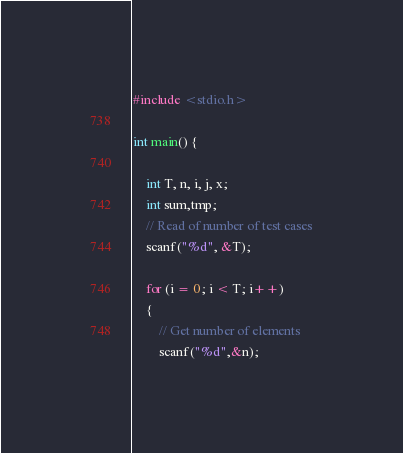Convert code to text. <code><loc_0><loc_0><loc_500><loc_500><_C_>#include <stdio.h>

int main() {

	int T, n, i, j, x;
	int sum,tmp;
	// Read of number of test cases
	scanf("%d", &T);

	for (i = 0; i < T; i++)
	{
	    // Get number of elements
	    scanf("%d",&n);
</code> 